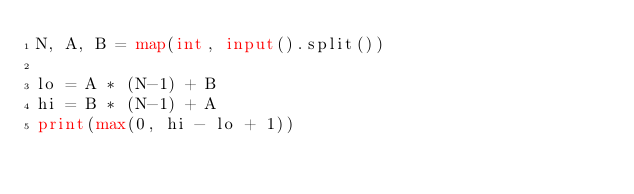<code> <loc_0><loc_0><loc_500><loc_500><_Python_>N, A, B = map(int, input().split())

lo = A * (N-1) + B
hi = B * (N-1) + A
print(max(0, hi - lo + 1))
</code> 